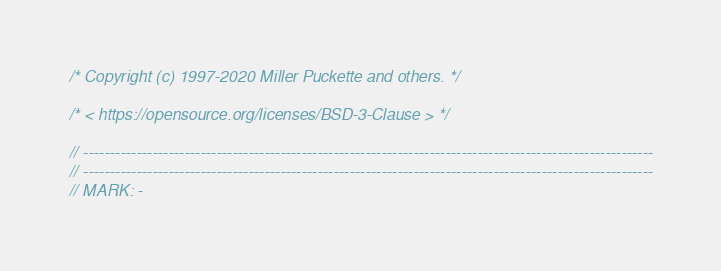Convert code to text. <code><loc_0><loc_0><loc_500><loc_500><_C_>
/* Copyright (c) 1997-2020 Miller Puckette and others. */

/* < https://opensource.org/licenses/BSD-3-Clause > */

// -----------------------------------------------------------------------------------------------------------
// -----------------------------------------------------------------------------------------------------------
// MARK: -
</code> 